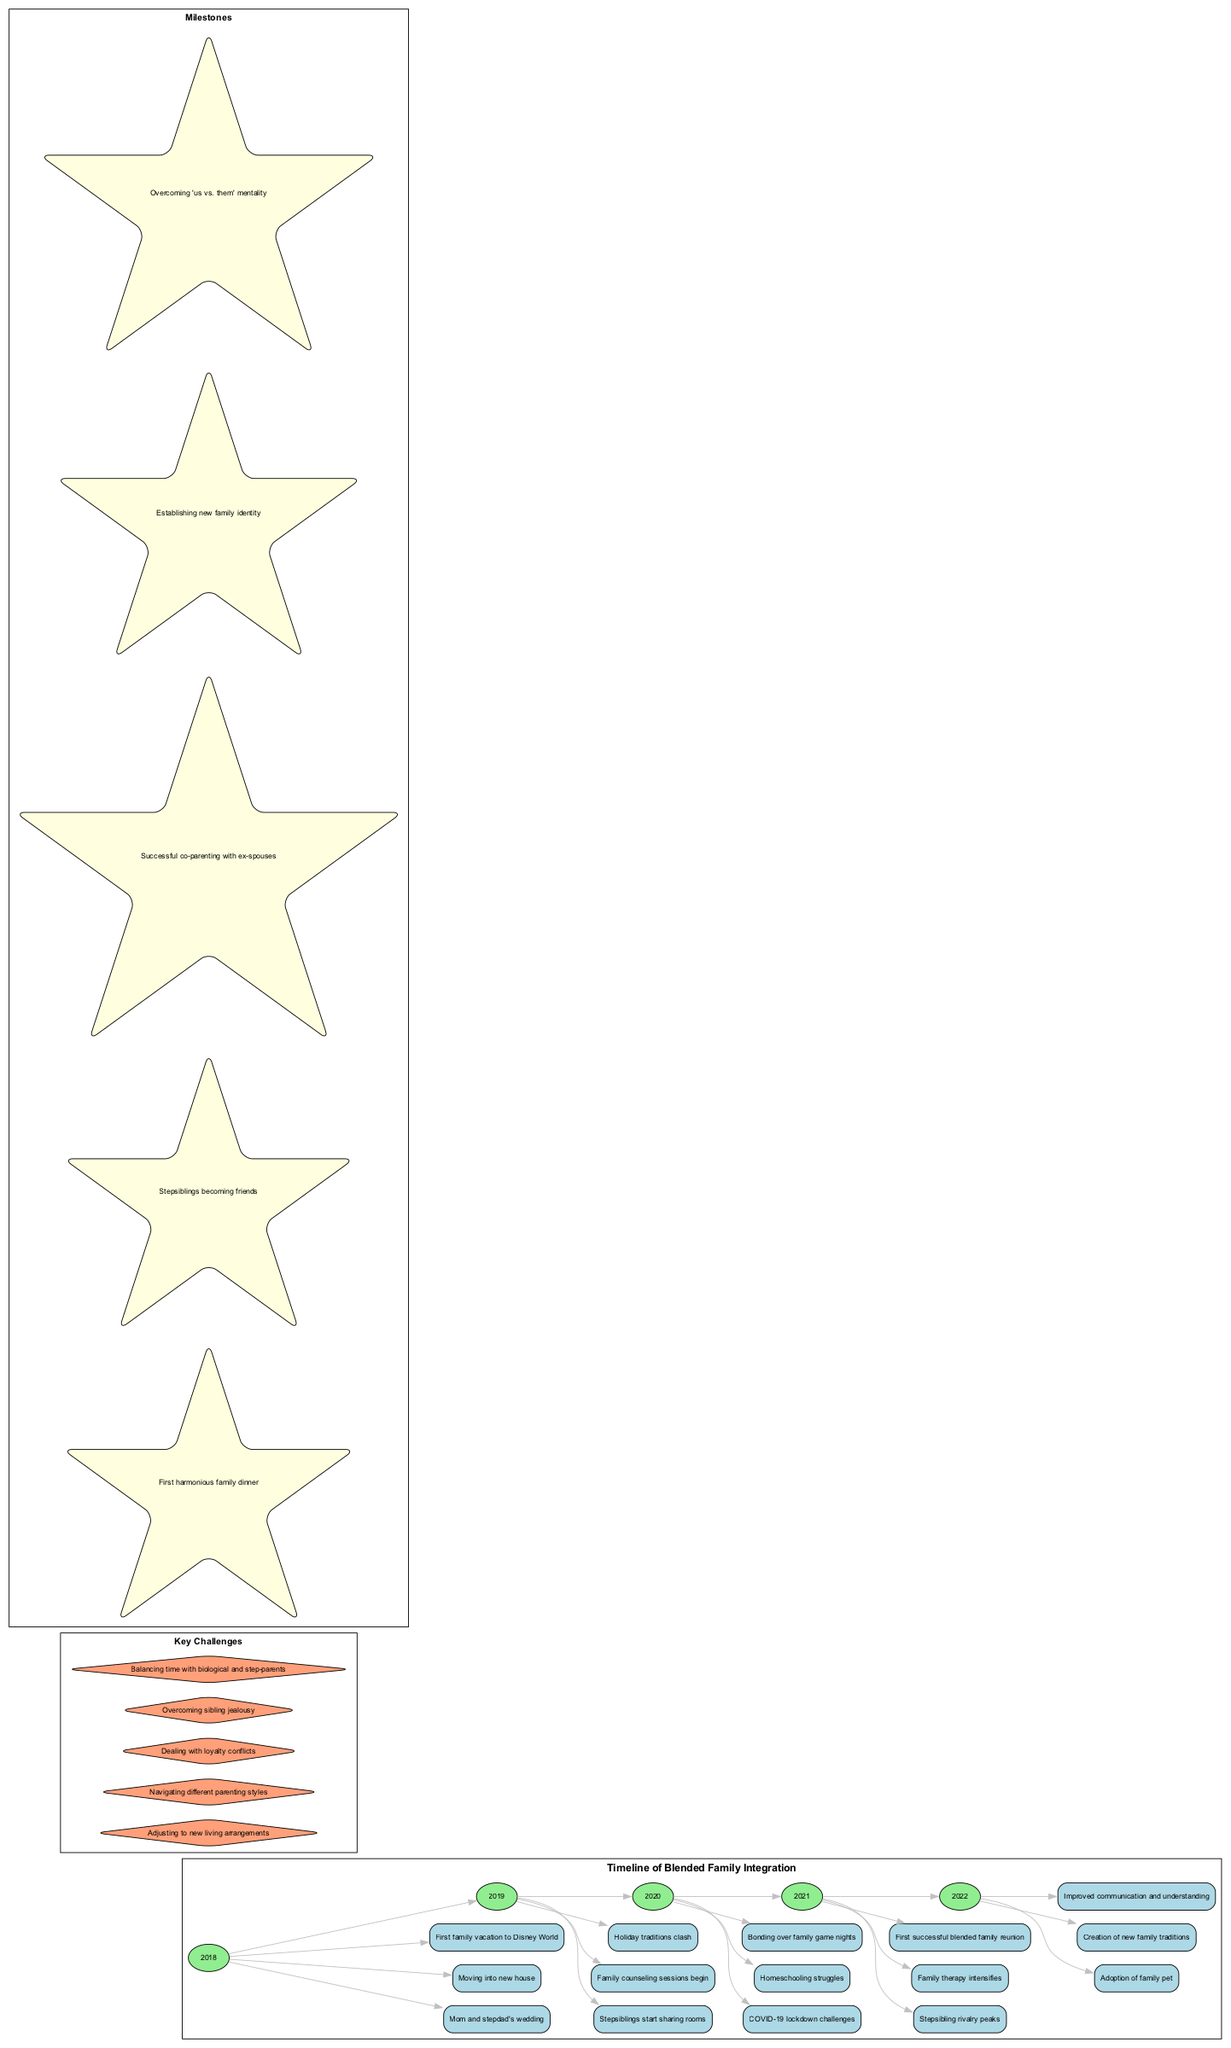What year did the family move into a new house? The event "Moving into new house" is assigned to the year 2018 in the timeline section of the diagram.
Answer: 2018 What is one key challenge faced in 2019? From the timeline, the events list for the year 2019 includes "Stepsiblings start sharing rooms," "Family counseling sessions begin," and "Holiday traditions clash." Any of these can be considered a key challenge, but the specific wording 'navigating different parenting styles' is also noted among key challenges overall.
Answer: Navigating different parenting styles How many milestones are depicted in the timeline? There are five milestones listed in the milestones section of the diagram, which is shown distinctly from the timeline of events.
Answer: Five Which year experienced the highest sibling rivalry? The timeline clearly states that "Stepsibling rivalry peaks" occurred in 2021, indicating this year experienced the highest level of rivalry among stepsiblings.
Answer: 2021 During which year was the first successful blended family reunion held? According to the timeline, the "First successful blended family reunion" is specified in the events for the year 2021, pinpointing that year as significant for this milestone.
Answer: 2021 What was a family challenge during the COVID-19 lockdown? The event "COVID-19 lockdown challenges" directly points to some of the struggles faced during 2020, indicating that this specific challenge arose during the pandemic year.
Answer: COVID-19 lockdown challenges What is one of the milestones achieved by 2022? The timeline lists "Creation of new family traditions" as one of the events occurring in 2022, showcasing it as a significant achievement for the family within that year.
Answer: Creation of new family traditions Which event marked the first family vacation? The timeline reveals that the event listed as "First family vacation to Disney World" occurred in 2018, marking this as the initial family vacation experience.
Answer: First family vacation to Disney World What was established to improve family dynamics in 2022? The event "Improved communication and understanding" designated in 2022 illustrates a significant goal and achievement aimed at enhancing family dynamics during that year.
Answer: Improved communication and understanding 